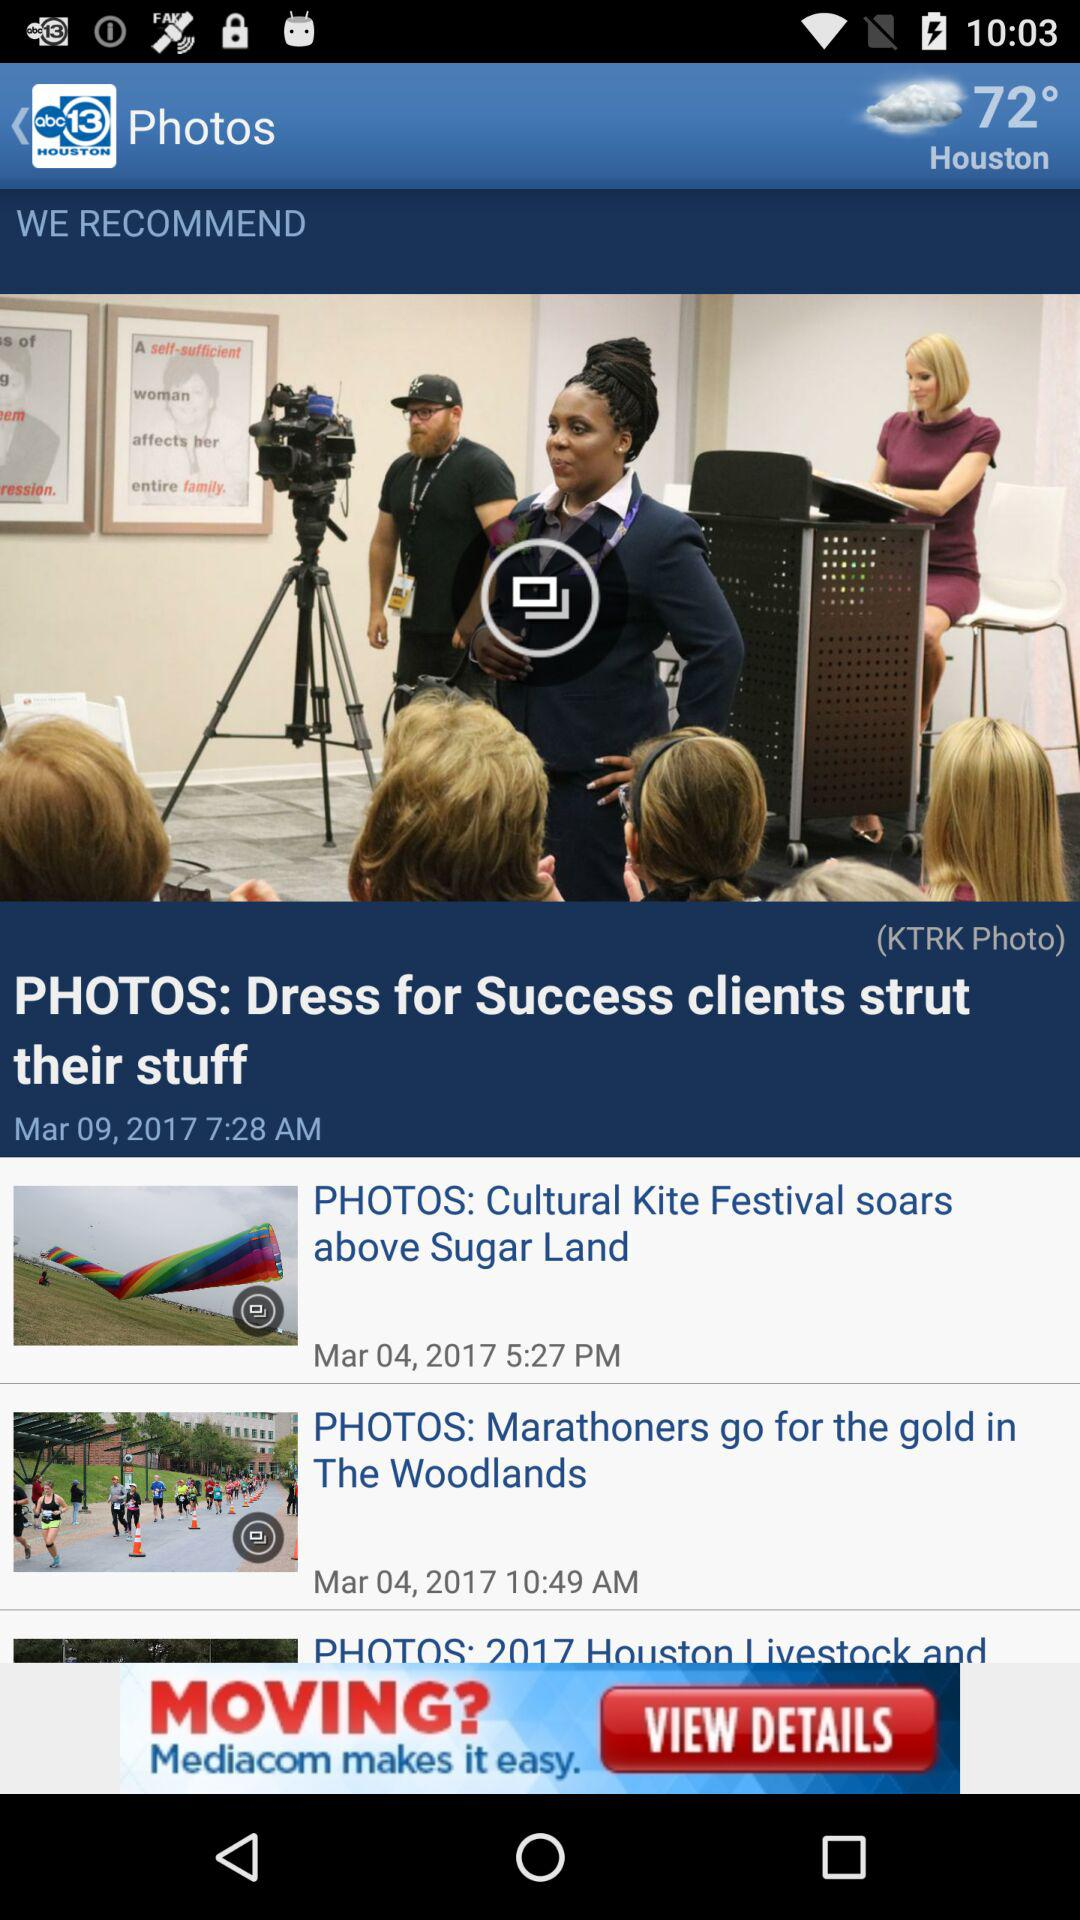What is the temperature in "Houston"? The temperature is 72°. 